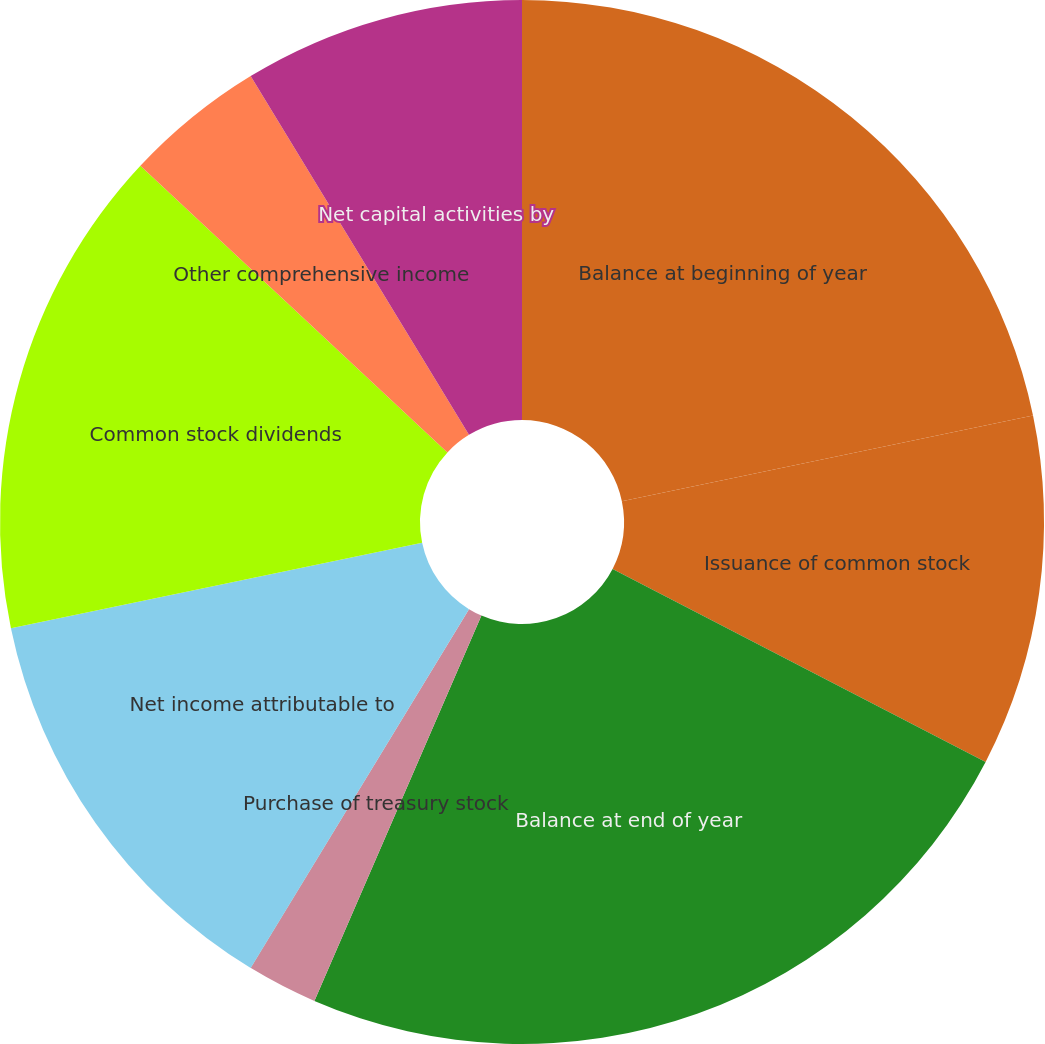Convert chart to OTSL. <chart><loc_0><loc_0><loc_500><loc_500><pie_chart><fcel>Balance at beginning of year<fcel>Issuance of common stock<fcel>Balance at end of year<fcel>Purchase of treasury stock<fcel>compensation<fcel>Net income attributable to<fcel>Common stock dividends<fcel>Other comprehensive income<fcel>Net capital activities by<nl><fcel>21.73%<fcel>10.87%<fcel>23.91%<fcel>2.18%<fcel>0.01%<fcel>13.04%<fcel>15.21%<fcel>4.35%<fcel>8.7%<nl></chart> 